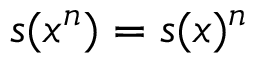Convert formula to latex. <formula><loc_0><loc_0><loc_500><loc_500>s ( x ^ { n } ) = s ( x ) ^ { n }</formula> 